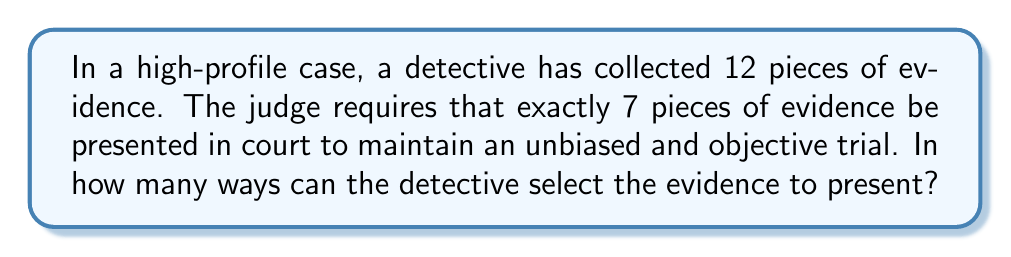Can you solve this math problem? To solve this problem, we need to use the concept of combinations from discrete mathematics. This scenario is a perfect example of choosing a subset from a larger set without regard to order.

1) We have a total of 12 pieces of evidence (n = 12).
2) We need to choose 7 pieces to present (k = 7).
3) The order of selection doesn't matter (it's a combination, not a permutation).

The formula for combinations is:

$$ C(n,k) = \binom{n}{k} = \frac{n!}{k!(n-k)!} $$

Where:
- n is the total number of items to choose from
- k is the number of items being chosen
- n! denotes the factorial of n

Substituting our values:

$$ C(12,7) = \binom{12}{7} = \frac{12!}{7!(12-7)!} = \frac{12!}{7!(5)!} $$

Now, let's calculate this step-by-step:

$$ \frac{12 \cdot 11 \cdot 10 \cdot 9 \cdot 8 \cdot 7 \cdot 6 \cdot 5!}{(7 \cdot 6 \cdot 5 \cdot 4 \cdot 3 \cdot 2 \cdot 1)(5!)} $$

The 5! cancels out in the numerator and denominator:

$$ \frac{12 \cdot 11 \cdot 10 \cdot 9 \cdot 8}{(7 \cdot 6 \cdot 5 \cdot 4 \cdot 3 \cdot 2 \cdot 1)} $$

$$ = \frac{95040}{5040} = 792 $$

Therefore, there are 792 ways to select 7 pieces of evidence from a total of 12.
Answer: 792 